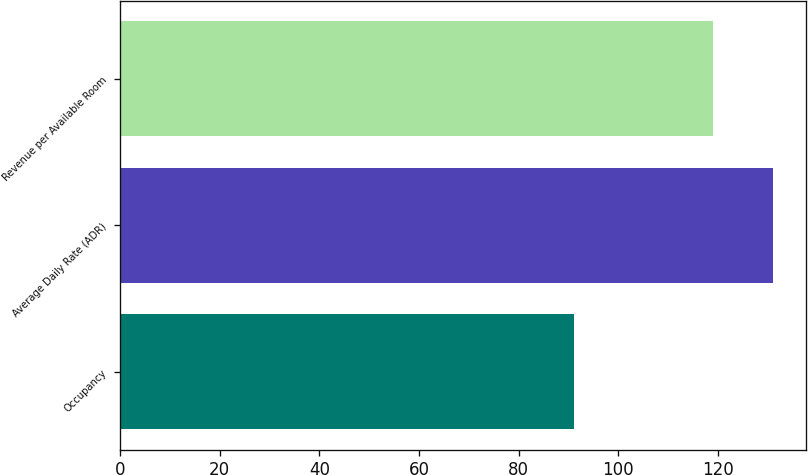<chart> <loc_0><loc_0><loc_500><loc_500><bar_chart><fcel>Occupancy<fcel>Average Daily Rate (ADR)<fcel>Revenue per Available Room<nl><fcel>91<fcel>131<fcel>119<nl></chart> 